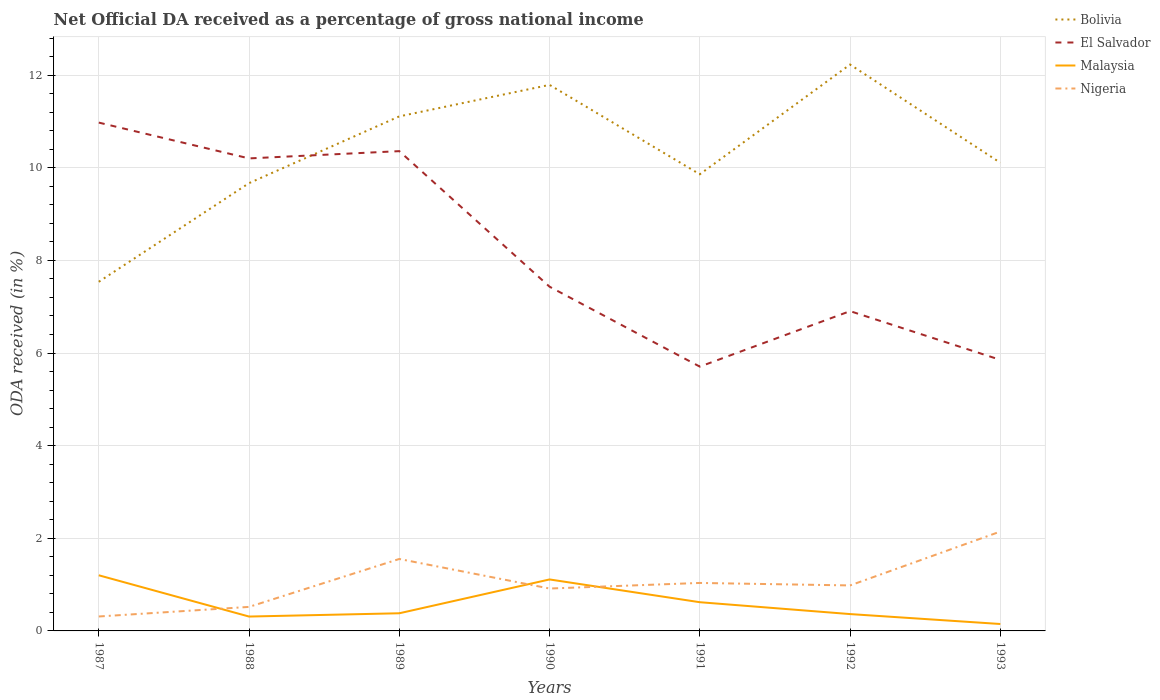How many different coloured lines are there?
Provide a succinct answer. 4. Across all years, what is the maximum net official DA received in Malaysia?
Your answer should be very brief. 0.15. What is the total net official DA received in Nigeria in the graph?
Provide a short and direct response. -0.07. What is the difference between the highest and the second highest net official DA received in Nigeria?
Offer a terse response. 1.83. Is the net official DA received in El Salvador strictly greater than the net official DA received in Bolivia over the years?
Your answer should be very brief. No. How many lines are there?
Make the answer very short. 4. Does the graph contain any zero values?
Your answer should be compact. No. How many legend labels are there?
Offer a terse response. 4. How are the legend labels stacked?
Provide a succinct answer. Vertical. What is the title of the graph?
Your answer should be compact. Net Official DA received as a percentage of gross national income. Does "Syrian Arab Republic" appear as one of the legend labels in the graph?
Keep it short and to the point. No. What is the label or title of the Y-axis?
Make the answer very short. ODA received (in %). What is the ODA received (in %) of Bolivia in 1987?
Provide a succinct answer. 7.54. What is the ODA received (in %) of El Salvador in 1987?
Keep it short and to the point. 10.98. What is the ODA received (in %) in Malaysia in 1987?
Offer a very short reply. 1.2. What is the ODA received (in %) in Nigeria in 1987?
Keep it short and to the point. 0.31. What is the ODA received (in %) of Bolivia in 1988?
Offer a very short reply. 9.67. What is the ODA received (in %) in El Salvador in 1988?
Give a very brief answer. 10.2. What is the ODA received (in %) of Malaysia in 1988?
Your answer should be very brief. 0.31. What is the ODA received (in %) in Nigeria in 1988?
Your answer should be compact. 0.52. What is the ODA received (in %) of Bolivia in 1989?
Your answer should be very brief. 11.11. What is the ODA received (in %) of El Salvador in 1989?
Provide a succinct answer. 10.36. What is the ODA received (in %) of Malaysia in 1989?
Offer a terse response. 0.38. What is the ODA received (in %) in Nigeria in 1989?
Provide a short and direct response. 1.55. What is the ODA received (in %) of Bolivia in 1990?
Make the answer very short. 11.79. What is the ODA received (in %) in El Salvador in 1990?
Keep it short and to the point. 7.43. What is the ODA received (in %) in Malaysia in 1990?
Ensure brevity in your answer.  1.11. What is the ODA received (in %) in Nigeria in 1990?
Provide a short and direct response. 0.92. What is the ODA received (in %) in Bolivia in 1991?
Give a very brief answer. 9.86. What is the ODA received (in %) in El Salvador in 1991?
Offer a terse response. 5.71. What is the ODA received (in %) in Malaysia in 1991?
Make the answer very short. 0.62. What is the ODA received (in %) in Nigeria in 1991?
Give a very brief answer. 1.04. What is the ODA received (in %) of Bolivia in 1992?
Give a very brief answer. 12.23. What is the ODA received (in %) of El Salvador in 1992?
Offer a terse response. 6.9. What is the ODA received (in %) in Malaysia in 1992?
Provide a succinct answer. 0.36. What is the ODA received (in %) in Nigeria in 1992?
Your answer should be very brief. 0.98. What is the ODA received (in %) of Bolivia in 1993?
Give a very brief answer. 10.11. What is the ODA received (in %) of El Salvador in 1993?
Offer a very short reply. 5.85. What is the ODA received (in %) in Malaysia in 1993?
Offer a terse response. 0.15. What is the ODA received (in %) of Nigeria in 1993?
Ensure brevity in your answer.  2.15. Across all years, what is the maximum ODA received (in %) in Bolivia?
Your response must be concise. 12.23. Across all years, what is the maximum ODA received (in %) in El Salvador?
Make the answer very short. 10.98. Across all years, what is the maximum ODA received (in %) of Malaysia?
Offer a terse response. 1.2. Across all years, what is the maximum ODA received (in %) of Nigeria?
Keep it short and to the point. 2.15. Across all years, what is the minimum ODA received (in %) of Bolivia?
Provide a short and direct response. 7.54. Across all years, what is the minimum ODA received (in %) in El Salvador?
Provide a succinct answer. 5.71. Across all years, what is the minimum ODA received (in %) in Malaysia?
Give a very brief answer. 0.15. Across all years, what is the minimum ODA received (in %) of Nigeria?
Give a very brief answer. 0.31. What is the total ODA received (in %) in Bolivia in the graph?
Offer a very short reply. 72.3. What is the total ODA received (in %) in El Salvador in the graph?
Give a very brief answer. 57.43. What is the total ODA received (in %) of Malaysia in the graph?
Keep it short and to the point. 4.14. What is the total ODA received (in %) in Nigeria in the graph?
Your answer should be compact. 7.46. What is the difference between the ODA received (in %) of Bolivia in 1987 and that in 1988?
Provide a succinct answer. -2.13. What is the difference between the ODA received (in %) in El Salvador in 1987 and that in 1988?
Your answer should be compact. 0.77. What is the difference between the ODA received (in %) in Malaysia in 1987 and that in 1988?
Your response must be concise. 0.89. What is the difference between the ODA received (in %) in Nigeria in 1987 and that in 1988?
Keep it short and to the point. -0.21. What is the difference between the ODA received (in %) of Bolivia in 1987 and that in 1989?
Offer a terse response. -3.57. What is the difference between the ODA received (in %) of El Salvador in 1987 and that in 1989?
Ensure brevity in your answer.  0.62. What is the difference between the ODA received (in %) in Malaysia in 1987 and that in 1989?
Your response must be concise. 0.82. What is the difference between the ODA received (in %) in Nigeria in 1987 and that in 1989?
Ensure brevity in your answer.  -1.24. What is the difference between the ODA received (in %) of Bolivia in 1987 and that in 1990?
Ensure brevity in your answer.  -4.25. What is the difference between the ODA received (in %) in El Salvador in 1987 and that in 1990?
Provide a short and direct response. 3.54. What is the difference between the ODA received (in %) in Malaysia in 1987 and that in 1990?
Your response must be concise. 0.09. What is the difference between the ODA received (in %) in Nigeria in 1987 and that in 1990?
Offer a terse response. -0.6. What is the difference between the ODA received (in %) of Bolivia in 1987 and that in 1991?
Your answer should be compact. -2.32. What is the difference between the ODA received (in %) in El Salvador in 1987 and that in 1991?
Your answer should be compact. 5.27. What is the difference between the ODA received (in %) in Malaysia in 1987 and that in 1991?
Your response must be concise. 0.58. What is the difference between the ODA received (in %) in Nigeria in 1987 and that in 1991?
Give a very brief answer. -0.72. What is the difference between the ODA received (in %) in Bolivia in 1987 and that in 1992?
Keep it short and to the point. -4.69. What is the difference between the ODA received (in %) of El Salvador in 1987 and that in 1992?
Ensure brevity in your answer.  4.07. What is the difference between the ODA received (in %) in Malaysia in 1987 and that in 1992?
Give a very brief answer. 0.84. What is the difference between the ODA received (in %) in Nigeria in 1987 and that in 1992?
Make the answer very short. -0.67. What is the difference between the ODA received (in %) of Bolivia in 1987 and that in 1993?
Your answer should be compact. -2.57. What is the difference between the ODA received (in %) of El Salvador in 1987 and that in 1993?
Provide a short and direct response. 5.12. What is the difference between the ODA received (in %) in Malaysia in 1987 and that in 1993?
Your answer should be very brief. 1.05. What is the difference between the ODA received (in %) of Nigeria in 1987 and that in 1993?
Keep it short and to the point. -1.83. What is the difference between the ODA received (in %) of Bolivia in 1988 and that in 1989?
Offer a terse response. -1.44. What is the difference between the ODA received (in %) in El Salvador in 1988 and that in 1989?
Provide a short and direct response. -0.16. What is the difference between the ODA received (in %) in Malaysia in 1988 and that in 1989?
Your response must be concise. -0.07. What is the difference between the ODA received (in %) of Nigeria in 1988 and that in 1989?
Your answer should be very brief. -1.03. What is the difference between the ODA received (in %) in Bolivia in 1988 and that in 1990?
Offer a terse response. -2.12. What is the difference between the ODA received (in %) of El Salvador in 1988 and that in 1990?
Make the answer very short. 2.77. What is the difference between the ODA received (in %) of Malaysia in 1988 and that in 1990?
Offer a terse response. -0.8. What is the difference between the ODA received (in %) of Nigeria in 1988 and that in 1990?
Make the answer very short. -0.4. What is the difference between the ODA received (in %) in Bolivia in 1988 and that in 1991?
Keep it short and to the point. -0.19. What is the difference between the ODA received (in %) in El Salvador in 1988 and that in 1991?
Your response must be concise. 4.5. What is the difference between the ODA received (in %) of Malaysia in 1988 and that in 1991?
Keep it short and to the point. -0.31. What is the difference between the ODA received (in %) in Nigeria in 1988 and that in 1991?
Your answer should be very brief. -0.52. What is the difference between the ODA received (in %) in Bolivia in 1988 and that in 1992?
Make the answer very short. -2.56. What is the difference between the ODA received (in %) of El Salvador in 1988 and that in 1992?
Provide a succinct answer. 3.3. What is the difference between the ODA received (in %) of Malaysia in 1988 and that in 1992?
Your answer should be very brief. -0.05. What is the difference between the ODA received (in %) in Nigeria in 1988 and that in 1992?
Your answer should be very brief. -0.46. What is the difference between the ODA received (in %) in Bolivia in 1988 and that in 1993?
Make the answer very short. -0.44. What is the difference between the ODA received (in %) of El Salvador in 1988 and that in 1993?
Your answer should be compact. 4.35. What is the difference between the ODA received (in %) in Malaysia in 1988 and that in 1993?
Your response must be concise. 0.16. What is the difference between the ODA received (in %) in Nigeria in 1988 and that in 1993?
Provide a short and direct response. -1.63. What is the difference between the ODA received (in %) of Bolivia in 1989 and that in 1990?
Your answer should be very brief. -0.68. What is the difference between the ODA received (in %) of El Salvador in 1989 and that in 1990?
Provide a succinct answer. 2.93. What is the difference between the ODA received (in %) of Malaysia in 1989 and that in 1990?
Keep it short and to the point. -0.73. What is the difference between the ODA received (in %) of Nigeria in 1989 and that in 1990?
Give a very brief answer. 0.64. What is the difference between the ODA received (in %) in Bolivia in 1989 and that in 1991?
Your response must be concise. 1.25. What is the difference between the ODA received (in %) of El Salvador in 1989 and that in 1991?
Provide a short and direct response. 4.65. What is the difference between the ODA received (in %) in Malaysia in 1989 and that in 1991?
Make the answer very short. -0.24. What is the difference between the ODA received (in %) in Nigeria in 1989 and that in 1991?
Your answer should be compact. 0.52. What is the difference between the ODA received (in %) of Bolivia in 1989 and that in 1992?
Keep it short and to the point. -1.12. What is the difference between the ODA received (in %) in El Salvador in 1989 and that in 1992?
Make the answer very short. 3.45. What is the difference between the ODA received (in %) of Malaysia in 1989 and that in 1992?
Your answer should be very brief. 0.02. What is the difference between the ODA received (in %) of Nigeria in 1989 and that in 1992?
Provide a succinct answer. 0.57. What is the difference between the ODA received (in %) in Bolivia in 1989 and that in 1993?
Keep it short and to the point. 1. What is the difference between the ODA received (in %) in El Salvador in 1989 and that in 1993?
Your answer should be very brief. 4.51. What is the difference between the ODA received (in %) in Malaysia in 1989 and that in 1993?
Provide a short and direct response. 0.23. What is the difference between the ODA received (in %) of Nigeria in 1989 and that in 1993?
Your answer should be compact. -0.59. What is the difference between the ODA received (in %) of Bolivia in 1990 and that in 1991?
Offer a very short reply. 1.93. What is the difference between the ODA received (in %) of El Salvador in 1990 and that in 1991?
Ensure brevity in your answer.  1.73. What is the difference between the ODA received (in %) of Malaysia in 1990 and that in 1991?
Provide a succinct answer. 0.49. What is the difference between the ODA received (in %) of Nigeria in 1990 and that in 1991?
Your answer should be very brief. -0.12. What is the difference between the ODA received (in %) of Bolivia in 1990 and that in 1992?
Provide a short and direct response. -0.44. What is the difference between the ODA received (in %) in El Salvador in 1990 and that in 1992?
Your response must be concise. 0.53. What is the difference between the ODA received (in %) in Malaysia in 1990 and that in 1992?
Ensure brevity in your answer.  0.75. What is the difference between the ODA received (in %) in Nigeria in 1990 and that in 1992?
Give a very brief answer. -0.07. What is the difference between the ODA received (in %) in Bolivia in 1990 and that in 1993?
Offer a terse response. 1.68. What is the difference between the ODA received (in %) in El Salvador in 1990 and that in 1993?
Offer a terse response. 1.58. What is the difference between the ODA received (in %) in Malaysia in 1990 and that in 1993?
Keep it short and to the point. 0.96. What is the difference between the ODA received (in %) of Nigeria in 1990 and that in 1993?
Provide a short and direct response. -1.23. What is the difference between the ODA received (in %) of Bolivia in 1991 and that in 1992?
Your response must be concise. -2.37. What is the difference between the ODA received (in %) in El Salvador in 1991 and that in 1992?
Offer a very short reply. -1.2. What is the difference between the ODA received (in %) in Malaysia in 1991 and that in 1992?
Give a very brief answer. 0.26. What is the difference between the ODA received (in %) of Nigeria in 1991 and that in 1992?
Your answer should be very brief. 0.05. What is the difference between the ODA received (in %) of Bolivia in 1991 and that in 1993?
Provide a short and direct response. -0.25. What is the difference between the ODA received (in %) in El Salvador in 1991 and that in 1993?
Your response must be concise. -0.15. What is the difference between the ODA received (in %) in Malaysia in 1991 and that in 1993?
Offer a very short reply. 0.47. What is the difference between the ODA received (in %) of Nigeria in 1991 and that in 1993?
Provide a succinct answer. -1.11. What is the difference between the ODA received (in %) in Bolivia in 1992 and that in 1993?
Offer a very short reply. 2.12. What is the difference between the ODA received (in %) in El Salvador in 1992 and that in 1993?
Your answer should be compact. 1.05. What is the difference between the ODA received (in %) in Malaysia in 1992 and that in 1993?
Provide a succinct answer. 0.21. What is the difference between the ODA received (in %) of Nigeria in 1992 and that in 1993?
Give a very brief answer. -1.16. What is the difference between the ODA received (in %) of Bolivia in 1987 and the ODA received (in %) of El Salvador in 1988?
Keep it short and to the point. -2.66. What is the difference between the ODA received (in %) of Bolivia in 1987 and the ODA received (in %) of Malaysia in 1988?
Keep it short and to the point. 7.23. What is the difference between the ODA received (in %) of Bolivia in 1987 and the ODA received (in %) of Nigeria in 1988?
Your answer should be very brief. 7.02. What is the difference between the ODA received (in %) of El Salvador in 1987 and the ODA received (in %) of Malaysia in 1988?
Give a very brief answer. 10.66. What is the difference between the ODA received (in %) in El Salvador in 1987 and the ODA received (in %) in Nigeria in 1988?
Provide a short and direct response. 10.46. What is the difference between the ODA received (in %) in Malaysia in 1987 and the ODA received (in %) in Nigeria in 1988?
Make the answer very short. 0.68. What is the difference between the ODA received (in %) of Bolivia in 1987 and the ODA received (in %) of El Salvador in 1989?
Your answer should be very brief. -2.82. What is the difference between the ODA received (in %) in Bolivia in 1987 and the ODA received (in %) in Malaysia in 1989?
Offer a terse response. 7.16. What is the difference between the ODA received (in %) in Bolivia in 1987 and the ODA received (in %) in Nigeria in 1989?
Ensure brevity in your answer.  5.98. What is the difference between the ODA received (in %) in El Salvador in 1987 and the ODA received (in %) in Malaysia in 1989?
Give a very brief answer. 10.59. What is the difference between the ODA received (in %) of El Salvador in 1987 and the ODA received (in %) of Nigeria in 1989?
Offer a terse response. 9.42. What is the difference between the ODA received (in %) in Malaysia in 1987 and the ODA received (in %) in Nigeria in 1989?
Offer a terse response. -0.35. What is the difference between the ODA received (in %) of Bolivia in 1987 and the ODA received (in %) of El Salvador in 1990?
Your answer should be very brief. 0.11. What is the difference between the ODA received (in %) of Bolivia in 1987 and the ODA received (in %) of Malaysia in 1990?
Provide a short and direct response. 6.43. What is the difference between the ODA received (in %) in Bolivia in 1987 and the ODA received (in %) in Nigeria in 1990?
Offer a terse response. 6.62. What is the difference between the ODA received (in %) in El Salvador in 1987 and the ODA received (in %) in Malaysia in 1990?
Your response must be concise. 9.86. What is the difference between the ODA received (in %) of El Salvador in 1987 and the ODA received (in %) of Nigeria in 1990?
Give a very brief answer. 10.06. What is the difference between the ODA received (in %) of Malaysia in 1987 and the ODA received (in %) of Nigeria in 1990?
Offer a very short reply. 0.29. What is the difference between the ODA received (in %) in Bolivia in 1987 and the ODA received (in %) in El Salvador in 1991?
Your answer should be very brief. 1.83. What is the difference between the ODA received (in %) in Bolivia in 1987 and the ODA received (in %) in Malaysia in 1991?
Ensure brevity in your answer.  6.92. What is the difference between the ODA received (in %) in Bolivia in 1987 and the ODA received (in %) in Nigeria in 1991?
Provide a succinct answer. 6.5. What is the difference between the ODA received (in %) of El Salvador in 1987 and the ODA received (in %) of Malaysia in 1991?
Keep it short and to the point. 10.36. What is the difference between the ODA received (in %) in El Salvador in 1987 and the ODA received (in %) in Nigeria in 1991?
Give a very brief answer. 9.94. What is the difference between the ODA received (in %) of Malaysia in 1987 and the ODA received (in %) of Nigeria in 1991?
Offer a very short reply. 0.17. What is the difference between the ODA received (in %) of Bolivia in 1987 and the ODA received (in %) of El Salvador in 1992?
Ensure brevity in your answer.  0.63. What is the difference between the ODA received (in %) of Bolivia in 1987 and the ODA received (in %) of Malaysia in 1992?
Give a very brief answer. 7.17. What is the difference between the ODA received (in %) in Bolivia in 1987 and the ODA received (in %) in Nigeria in 1992?
Make the answer very short. 6.56. What is the difference between the ODA received (in %) in El Salvador in 1987 and the ODA received (in %) in Malaysia in 1992?
Keep it short and to the point. 10.61. What is the difference between the ODA received (in %) of El Salvador in 1987 and the ODA received (in %) of Nigeria in 1992?
Ensure brevity in your answer.  9.99. What is the difference between the ODA received (in %) of Malaysia in 1987 and the ODA received (in %) of Nigeria in 1992?
Provide a short and direct response. 0.22. What is the difference between the ODA received (in %) of Bolivia in 1987 and the ODA received (in %) of El Salvador in 1993?
Give a very brief answer. 1.69. What is the difference between the ODA received (in %) of Bolivia in 1987 and the ODA received (in %) of Malaysia in 1993?
Make the answer very short. 7.39. What is the difference between the ODA received (in %) of Bolivia in 1987 and the ODA received (in %) of Nigeria in 1993?
Ensure brevity in your answer.  5.39. What is the difference between the ODA received (in %) in El Salvador in 1987 and the ODA received (in %) in Malaysia in 1993?
Your answer should be compact. 10.83. What is the difference between the ODA received (in %) in El Salvador in 1987 and the ODA received (in %) in Nigeria in 1993?
Your answer should be compact. 8.83. What is the difference between the ODA received (in %) of Malaysia in 1987 and the ODA received (in %) of Nigeria in 1993?
Provide a succinct answer. -0.94. What is the difference between the ODA received (in %) in Bolivia in 1988 and the ODA received (in %) in El Salvador in 1989?
Provide a succinct answer. -0.69. What is the difference between the ODA received (in %) of Bolivia in 1988 and the ODA received (in %) of Malaysia in 1989?
Provide a succinct answer. 9.29. What is the difference between the ODA received (in %) in Bolivia in 1988 and the ODA received (in %) in Nigeria in 1989?
Offer a very short reply. 8.11. What is the difference between the ODA received (in %) of El Salvador in 1988 and the ODA received (in %) of Malaysia in 1989?
Your response must be concise. 9.82. What is the difference between the ODA received (in %) in El Salvador in 1988 and the ODA received (in %) in Nigeria in 1989?
Offer a terse response. 8.65. What is the difference between the ODA received (in %) of Malaysia in 1988 and the ODA received (in %) of Nigeria in 1989?
Give a very brief answer. -1.24. What is the difference between the ODA received (in %) of Bolivia in 1988 and the ODA received (in %) of El Salvador in 1990?
Make the answer very short. 2.24. What is the difference between the ODA received (in %) of Bolivia in 1988 and the ODA received (in %) of Malaysia in 1990?
Provide a succinct answer. 8.56. What is the difference between the ODA received (in %) of Bolivia in 1988 and the ODA received (in %) of Nigeria in 1990?
Ensure brevity in your answer.  8.75. What is the difference between the ODA received (in %) in El Salvador in 1988 and the ODA received (in %) in Malaysia in 1990?
Keep it short and to the point. 9.09. What is the difference between the ODA received (in %) of El Salvador in 1988 and the ODA received (in %) of Nigeria in 1990?
Your response must be concise. 9.29. What is the difference between the ODA received (in %) of Malaysia in 1988 and the ODA received (in %) of Nigeria in 1990?
Your answer should be compact. -0.6. What is the difference between the ODA received (in %) of Bolivia in 1988 and the ODA received (in %) of El Salvador in 1991?
Your response must be concise. 3.96. What is the difference between the ODA received (in %) in Bolivia in 1988 and the ODA received (in %) in Malaysia in 1991?
Keep it short and to the point. 9.05. What is the difference between the ODA received (in %) in Bolivia in 1988 and the ODA received (in %) in Nigeria in 1991?
Your answer should be compact. 8.63. What is the difference between the ODA received (in %) of El Salvador in 1988 and the ODA received (in %) of Malaysia in 1991?
Keep it short and to the point. 9.58. What is the difference between the ODA received (in %) of El Salvador in 1988 and the ODA received (in %) of Nigeria in 1991?
Provide a short and direct response. 9.17. What is the difference between the ODA received (in %) in Malaysia in 1988 and the ODA received (in %) in Nigeria in 1991?
Provide a succinct answer. -0.73. What is the difference between the ODA received (in %) in Bolivia in 1988 and the ODA received (in %) in El Salvador in 1992?
Give a very brief answer. 2.76. What is the difference between the ODA received (in %) in Bolivia in 1988 and the ODA received (in %) in Malaysia in 1992?
Your response must be concise. 9.3. What is the difference between the ODA received (in %) of Bolivia in 1988 and the ODA received (in %) of Nigeria in 1992?
Give a very brief answer. 8.69. What is the difference between the ODA received (in %) of El Salvador in 1988 and the ODA received (in %) of Malaysia in 1992?
Give a very brief answer. 9.84. What is the difference between the ODA received (in %) of El Salvador in 1988 and the ODA received (in %) of Nigeria in 1992?
Provide a short and direct response. 9.22. What is the difference between the ODA received (in %) of Malaysia in 1988 and the ODA received (in %) of Nigeria in 1992?
Offer a very short reply. -0.67. What is the difference between the ODA received (in %) of Bolivia in 1988 and the ODA received (in %) of El Salvador in 1993?
Your answer should be very brief. 3.82. What is the difference between the ODA received (in %) of Bolivia in 1988 and the ODA received (in %) of Malaysia in 1993?
Ensure brevity in your answer.  9.52. What is the difference between the ODA received (in %) of Bolivia in 1988 and the ODA received (in %) of Nigeria in 1993?
Provide a succinct answer. 7.52. What is the difference between the ODA received (in %) in El Salvador in 1988 and the ODA received (in %) in Malaysia in 1993?
Offer a very short reply. 10.05. What is the difference between the ODA received (in %) of El Salvador in 1988 and the ODA received (in %) of Nigeria in 1993?
Provide a short and direct response. 8.06. What is the difference between the ODA received (in %) of Malaysia in 1988 and the ODA received (in %) of Nigeria in 1993?
Keep it short and to the point. -1.84. What is the difference between the ODA received (in %) of Bolivia in 1989 and the ODA received (in %) of El Salvador in 1990?
Offer a terse response. 3.68. What is the difference between the ODA received (in %) of Bolivia in 1989 and the ODA received (in %) of Malaysia in 1990?
Provide a succinct answer. 10. What is the difference between the ODA received (in %) in Bolivia in 1989 and the ODA received (in %) in Nigeria in 1990?
Offer a terse response. 10.19. What is the difference between the ODA received (in %) of El Salvador in 1989 and the ODA received (in %) of Malaysia in 1990?
Your response must be concise. 9.25. What is the difference between the ODA received (in %) in El Salvador in 1989 and the ODA received (in %) in Nigeria in 1990?
Your answer should be compact. 9.44. What is the difference between the ODA received (in %) in Malaysia in 1989 and the ODA received (in %) in Nigeria in 1990?
Provide a short and direct response. -0.53. What is the difference between the ODA received (in %) of Bolivia in 1989 and the ODA received (in %) of El Salvador in 1991?
Make the answer very short. 5.4. What is the difference between the ODA received (in %) in Bolivia in 1989 and the ODA received (in %) in Malaysia in 1991?
Your response must be concise. 10.49. What is the difference between the ODA received (in %) in Bolivia in 1989 and the ODA received (in %) in Nigeria in 1991?
Offer a very short reply. 10.07. What is the difference between the ODA received (in %) in El Salvador in 1989 and the ODA received (in %) in Malaysia in 1991?
Offer a terse response. 9.74. What is the difference between the ODA received (in %) of El Salvador in 1989 and the ODA received (in %) of Nigeria in 1991?
Your answer should be compact. 9.32. What is the difference between the ODA received (in %) of Malaysia in 1989 and the ODA received (in %) of Nigeria in 1991?
Your response must be concise. -0.65. What is the difference between the ODA received (in %) of Bolivia in 1989 and the ODA received (in %) of El Salvador in 1992?
Keep it short and to the point. 4.2. What is the difference between the ODA received (in %) of Bolivia in 1989 and the ODA received (in %) of Malaysia in 1992?
Your response must be concise. 10.75. What is the difference between the ODA received (in %) in Bolivia in 1989 and the ODA received (in %) in Nigeria in 1992?
Offer a very short reply. 10.13. What is the difference between the ODA received (in %) in El Salvador in 1989 and the ODA received (in %) in Malaysia in 1992?
Give a very brief answer. 10. What is the difference between the ODA received (in %) of El Salvador in 1989 and the ODA received (in %) of Nigeria in 1992?
Offer a very short reply. 9.38. What is the difference between the ODA received (in %) of Malaysia in 1989 and the ODA received (in %) of Nigeria in 1992?
Ensure brevity in your answer.  -0.6. What is the difference between the ODA received (in %) of Bolivia in 1989 and the ODA received (in %) of El Salvador in 1993?
Offer a terse response. 5.26. What is the difference between the ODA received (in %) of Bolivia in 1989 and the ODA received (in %) of Malaysia in 1993?
Your response must be concise. 10.96. What is the difference between the ODA received (in %) in Bolivia in 1989 and the ODA received (in %) in Nigeria in 1993?
Provide a succinct answer. 8.96. What is the difference between the ODA received (in %) of El Salvador in 1989 and the ODA received (in %) of Malaysia in 1993?
Ensure brevity in your answer.  10.21. What is the difference between the ODA received (in %) in El Salvador in 1989 and the ODA received (in %) in Nigeria in 1993?
Give a very brief answer. 8.21. What is the difference between the ODA received (in %) in Malaysia in 1989 and the ODA received (in %) in Nigeria in 1993?
Keep it short and to the point. -1.76. What is the difference between the ODA received (in %) in Bolivia in 1990 and the ODA received (in %) in El Salvador in 1991?
Make the answer very short. 6.08. What is the difference between the ODA received (in %) in Bolivia in 1990 and the ODA received (in %) in Malaysia in 1991?
Offer a very short reply. 11.17. What is the difference between the ODA received (in %) in Bolivia in 1990 and the ODA received (in %) in Nigeria in 1991?
Ensure brevity in your answer.  10.75. What is the difference between the ODA received (in %) of El Salvador in 1990 and the ODA received (in %) of Malaysia in 1991?
Provide a succinct answer. 6.81. What is the difference between the ODA received (in %) in El Salvador in 1990 and the ODA received (in %) in Nigeria in 1991?
Offer a terse response. 6.4. What is the difference between the ODA received (in %) in Malaysia in 1990 and the ODA received (in %) in Nigeria in 1991?
Offer a very short reply. 0.08. What is the difference between the ODA received (in %) of Bolivia in 1990 and the ODA received (in %) of El Salvador in 1992?
Offer a very short reply. 4.88. What is the difference between the ODA received (in %) in Bolivia in 1990 and the ODA received (in %) in Malaysia in 1992?
Offer a terse response. 11.43. What is the difference between the ODA received (in %) in Bolivia in 1990 and the ODA received (in %) in Nigeria in 1992?
Ensure brevity in your answer.  10.81. What is the difference between the ODA received (in %) in El Salvador in 1990 and the ODA received (in %) in Malaysia in 1992?
Your answer should be very brief. 7.07. What is the difference between the ODA received (in %) of El Salvador in 1990 and the ODA received (in %) of Nigeria in 1992?
Give a very brief answer. 6.45. What is the difference between the ODA received (in %) in Malaysia in 1990 and the ODA received (in %) in Nigeria in 1992?
Ensure brevity in your answer.  0.13. What is the difference between the ODA received (in %) of Bolivia in 1990 and the ODA received (in %) of El Salvador in 1993?
Your answer should be very brief. 5.94. What is the difference between the ODA received (in %) of Bolivia in 1990 and the ODA received (in %) of Malaysia in 1993?
Your response must be concise. 11.64. What is the difference between the ODA received (in %) of Bolivia in 1990 and the ODA received (in %) of Nigeria in 1993?
Provide a succinct answer. 9.64. What is the difference between the ODA received (in %) of El Salvador in 1990 and the ODA received (in %) of Malaysia in 1993?
Offer a terse response. 7.28. What is the difference between the ODA received (in %) of El Salvador in 1990 and the ODA received (in %) of Nigeria in 1993?
Provide a succinct answer. 5.29. What is the difference between the ODA received (in %) in Malaysia in 1990 and the ODA received (in %) in Nigeria in 1993?
Give a very brief answer. -1.03. What is the difference between the ODA received (in %) in Bolivia in 1991 and the ODA received (in %) in El Salvador in 1992?
Ensure brevity in your answer.  2.95. What is the difference between the ODA received (in %) of Bolivia in 1991 and the ODA received (in %) of Malaysia in 1992?
Provide a short and direct response. 9.5. What is the difference between the ODA received (in %) of Bolivia in 1991 and the ODA received (in %) of Nigeria in 1992?
Your answer should be very brief. 8.88. What is the difference between the ODA received (in %) in El Salvador in 1991 and the ODA received (in %) in Malaysia in 1992?
Provide a succinct answer. 5.34. What is the difference between the ODA received (in %) of El Salvador in 1991 and the ODA received (in %) of Nigeria in 1992?
Your answer should be compact. 4.72. What is the difference between the ODA received (in %) in Malaysia in 1991 and the ODA received (in %) in Nigeria in 1992?
Provide a short and direct response. -0.36. What is the difference between the ODA received (in %) in Bolivia in 1991 and the ODA received (in %) in El Salvador in 1993?
Make the answer very short. 4.01. What is the difference between the ODA received (in %) in Bolivia in 1991 and the ODA received (in %) in Malaysia in 1993?
Provide a succinct answer. 9.71. What is the difference between the ODA received (in %) of Bolivia in 1991 and the ODA received (in %) of Nigeria in 1993?
Ensure brevity in your answer.  7.71. What is the difference between the ODA received (in %) of El Salvador in 1991 and the ODA received (in %) of Malaysia in 1993?
Keep it short and to the point. 5.56. What is the difference between the ODA received (in %) in El Salvador in 1991 and the ODA received (in %) in Nigeria in 1993?
Your response must be concise. 3.56. What is the difference between the ODA received (in %) of Malaysia in 1991 and the ODA received (in %) of Nigeria in 1993?
Offer a very short reply. -1.53. What is the difference between the ODA received (in %) of Bolivia in 1992 and the ODA received (in %) of El Salvador in 1993?
Give a very brief answer. 6.38. What is the difference between the ODA received (in %) in Bolivia in 1992 and the ODA received (in %) in Malaysia in 1993?
Your answer should be compact. 12.08. What is the difference between the ODA received (in %) of Bolivia in 1992 and the ODA received (in %) of Nigeria in 1993?
Your answer should be compact. 10.08. What is the difference between the ODA received (in %) in El Salvador in 1992 and the ODA received (in %) in Malaysia in 1993?
Provide a succinct answer. 6.76. What is the difference between the ODA received (in %) of El Salvador in 1992 and the ODA received (in %) of Nigeria in 1993?
Offer a terse response. 4.76. What is the difference between the ODA received (in %) in Malaysia in 1992 and the ODA received (in %) in Nigeria in 1993?
Offer a very short reply. -1.78. What is the average ODA received (in %) in Bolivia per year?
Offer a very short reply. 10.33. What is the average ODA received (in %) in El Salvador per year?
Your answer should be compact. 8.2. What is the average ODA received (in %) of Malaysia per year?
Provide a short and direct response. 0.59. What is the average ODA received (in %) in Nigeria per year?
Offer a terse response. 1.07. In the year 1987, what is the difference between the ODA received (in %) of Bolivia and ODA received (in %) of El Salvador?
Offer a terse response. -3.44. In the year 1987, what is the difference between the ODA received (in %) of Bolivia and ODA received (in %) of Malaysia?
Your answer should be compact. 6.34. In the year 1987, what is the difference between the ODA received (in %) of Bolivia and ODA received (in %) of Nigeria?
Provide a succinct answer. 7.23. In the year 1987, what is the difference between the ODA received (in %) of El Salvador and ODA received (in %) of Malaysia?
Your answer should be compact. 9.77. In the year 1987, what is the difference between the ODA received (in %) in El Salvador and ODA received (in %) in Nigeria?
Make the answer very short. 10.66. In the year 1987, what is the difference between the ODA received (in %) of Malaysia and ODA received (in %) of Nigeria?
Your response must be concise. 0.89. In the year 1988, what is the difference between the ODA received (in %) of Bolivia and ODA received (in %) of El Salvador?
Offer a very short reply. -0.53. In the year 1988, what is the difference between the ODA received (in %) in Bolivia and ODA received (in %) in Malaysia?
Your response must be concise. 9.36. In the year 1988, what is the difference between the ODA received (in %) of Bolivia and ODA received (in %) of Nigeria?
Offer a terse response. 9.15. In the year 1988, what is the difference between the ODA received (in %) of El Salvador and ODA received (in %) of Malaysia?
Your answer should be compact. 9.89. In the year 1988, what is the difference between the ODA received (in %) in El Salvador and ODA received (in %) in Nigeria?
Your response must be concise. 9.68. In the year 1988, what is the difference between the ODA received (in %) of Malaysia and ODA received (in %) of Nigeria?
Make the answer very short. -0.21. In the year 1989, what is the difference between the ODA received (in %) of Bolivia and ODA received (in %) of El Salvador?
Your answer should be very brief. 0.75. In the year 1989, what is the difference between the ODA received (in %) of Bolivia and ODA received (in %) of Malaysia?
Your answer should be very brief. 10.73. In the year 1989, what is the difference between the ODA received (in %) in Bolivia and ODA received (in %) in Nigeria?
Offer a terse response. 9.56. In the year 1989, what is the difference between the ODA received (in %) in El Salvador and ODA received (in %) in Malaysia?
Keep it short and to the point. 9.98. In the year 1989, what is the difference between the ODA received (in %) in El Salvador and ODA received (in %) in Nigeria?
Your response must be concise. 8.81. In the year 1989, what is the difference between the ODA received (in %) in Malaysia and ODA received (in %) in Nigeria?
Make the answer very short. -1.17. In the year 1990, what is the difference between the ODA received (in %) in Bolivia and ODA received (in %) in El Salvador?
Provide a succinct answer. 4.36. In the year 1990, what is the difference between the ODA received (in %) in Bolivia and ODA received (in %) in Malaysia?
Provide a succinct answer. 10.68. In the year 1990, what is the difference between the ODA received (in %) in Bolivia and ODA received (in %) in Nigeria?
Your answer should be compact. 10.87. In the year 1990, what is the difference between the ODA received (in %) of El Salvador and ODA received (in %) of Malaysia?
Ensure brevity in your answer.  6.32. In the year 1990, what is the difference between the ODA received (in %) in El Salvador and ODA received (in %) in Nigeria?
Keep it short and to the point. 6.52. In the year 1990, what is the difference between the ODA received (in %) in Malaysia and ODA received (in %) in Nigeria?
Your answer should be compact. 0.2. In the year 1991, what is the difference between the ODA received (in %) in Bolivia and ODA received (in %) in El Salvador?
Offer a terse response. 4.15. In the year 1991, what is the difference between the ODA received (in %) in Bolivia and ODA received (in %) in Malaysia?
Provide a succinct answer. 9.24. In the year 1991, what is the difference between the ODA received (in %) of Bolivia and ODA received (in %) of Nigeria?
Your response must be concise. 8.82. In the year 1991, what is the difference between the ODA received (in %) in El Salvador and ODA received (in %) in Malaysia?
Offer a very short reply. 5.09. In the year 1991, what is the difference between the ODA received (in %) of El Salvador and ODA received (in %) of Nigeria?
Make the answer very short. 4.67. In the year 1991, what is the difference between the ODA received (in %) of Malaysia and ODA received (in %) of Nigeria?
Offer a terse response. -0.42. In the year 1992, what is the difference between the ODA received (in %) in Bolivia and ODA received (in %) in El Salvador?
Make the answer very short. 5.32. In the year 1992, what is the difference between the ODA received (in %) in Bolivia and ODA received (in %) in Malaysia?
Your response must be concise. 11.86. In the year 1992, what is the difference between the ODA received (in %) in Bolivia and ODA received (in %) in Nigeria?
Provide a short and direct response. 11.25. In the year 1992, what is the difference between the ODA received (in %) of El Salvador and ODA received (in %) of Malaysia?
Your response must be concise. 6.54. In the year 1992, what is the difference between the ODA received (in %) in El Salvador and ODA received (in %) in Nigeria?
Make the answer very short. 5.92. In the year 1992, what is the difference between the ODA received (in %) of Malaysia and ODA received (in %) of Nigeria?
Give a very brief answer. -0.62. In the year 1993, what is the difference between the ODA received (in %) in Bolivia and ODA received (in %) in El Salvador?
Keep it short and to the point. 4.26. In the year 1993, what is the difference between the ODA received (in %) in Bolivia and ODA received (in %) in Malaysia?
Your response must be concise. 9.96. In the year 1993, what is the difference between the ODA received (in %) in Bolivia and ODA received (in %) in Nigeria?
Ensure brevity in your answer.  7.96. In the year 1993, what is the difference between the ODA received (in %) of El Salvador and ODA received (in %) of Malaysia?
Make the answer very short. 5.7. In the year 1993, what is the difference between the ODA received (in %) in El Salvador and ODA received (in %) in Nigeria?
Your answer should be very brief. 3.71. In the year 1993, what is the difference between the ODA received (in %) of Malaysia and ODA received (in %) of Nigeria?
Give a very brief answer. -2. What is the ratio of the ODA received (in %) in Bolivia in 1987 to that in 1988?
Give a very brief answer. 0.78. What is the ratio of the ODA received (in %) in El Salvador in 1987 to that in 1988?
Provide a short and direct response. 1.08. What is the ratio of the ODA received (in %) of Malaysia in 1987 to that in 1988?
Make the answer very short. 3.87. What is the ratio of the ODA received (in %) in Nigeria in 1987 to that in 1988?
Keep it short and to the point. 0.6. What is the ratio of the ODA received (in %) in Bolivia in 1987 to that in 1989?
Offer a terse response. 0.68. What is the ratio of the ODA received (in %) in El Salvador in 1987 to that in 1989?
Offer a very short reply. 1.06. What is the ratio of the ODA received (in %) of Malaysia in 1987 to that in 1989?
Provide a succinct answer. 3.15. What is the ratio of the ODA received (in %) in Nigeria in 1987 to that in 1989?
Your answer should be compact. 0.2. What is the ratio of the ODA received (in %) of Bolivia in 1987 to that in 1990?
Your response must be concise. 0.64. What is the ratio of the ODA received (in %) in El Salvador in 1987 to that in 1990?
Your answer should be very brief. 1.48. What is the ratio of the ODA received (in %) of Malaysia in 1987 to that in 1990?
Offer a terse response. 1.08. What is the ratio of the ODA received (in %) of Nigeria in 1987 to that in 1990?
Your answer should be compact. 0.34. What is the ratio of the ODA received (in %) of Bolivia in 1987 to that in 1991?
Provide a succinct answer. 0.76. What is the ratio of the ODA received (in %) of El Salvador in 1987 to that in 1991?
Ensure brevity in your answer.  1.92. What is the ratio of the ODA received (in %) in Malaysia in 1987 to that in 1991?
Provide a short and direct response. 1.94. What is the ratio of the ODA received (in %) in Nigeria in 1987 to that in 1991?
Ensure brevity in your answer.  0.3. What is the ratio of the ODA received (in %) in Bolivia in 1987 to that in 1992?
Ensure brevity in your answer.  0.62. What is the ratio of the ODA received (in %) of El Salvador in 1987 to that in 1992?
Your answer should be very brief. 1.59. What is the ratio of the ODA received (in %) in Malaysia in 1987 to that in 1992?
Make the answer very short. 3.3. What is the ratio of the ODA received (in %) in Nigeria in 1987 to that in 1992?
Offer a very short reply. 0.32. What is the ratio of the ODA received (in %) of Bolivia in 1987 to that in 1993?
Offer a terse response. 0.75. What is the ratio of the ODA received (in %) of El Salvador in 1987 to that in 1993?
Offer a very short reply. 1.88. What is the ratio of the ODA received (in %) in Malaysia in 1987 to that in 1993?
Provide a short and direct response. 8.03. What is the ratio of the ODA received (in %) in Nigeria in 1987 to that in 1993?
Give a very brief answer. 0.15. What is the ratio of the ODA received (in %) of Bolivia in 1988 to that in 1989?
Provide a short and direct response. 0.87. What is the ratio of the ODA received (in %) in El Salvador in 1988 to that in 1989?
Your response must be concise. 0.98. What is the ratio of the ODA received (in %) in Malaysia in 1988 to that in 1989?
Ensure brevity in your answer.  0.81. What is the ratio of the ODA received (in %) in Nigeria in 1988 to that in 1989?
Provide a succinct answer. 0.33. What is the ratio of the ODA received (in %) of Bolivia in 1988 to that in 1990?
Offer a terse response. 0.82. What is the ratio of the ODA received (in %) of El Salvador in 1988 to that in 1990?
Keep it short and to the point. 1.37. What is the ratio of the ODA received (in %) of Malaysia in 1988 to that in 1990?
Provide a succinct answer. 0.28. What is the ratio of the ODA received (in %) in Nigeria in 1988 to that in 1990?
Offer a very short reply. 0.57. What is the ratio of the ODA received (in %) of Bolivia in 1988 to that in 1991?
Keep it short and to the point. 0.98. What is the ratio of the ODA received (in %) in El Salvador in 1988 to that in 1991?
Make the answer very short. 1.79. What is the ratio of the ODA received (in %) in Malaysia in 1988 to that in 1991?
Offer a very short reply. 0.5. What is the ratio of the ODA received (in %) in Nigeria in 1988 to that in 1991?
Your answer should be compact. 0.5. What is the ratio of the ODA received (in %) in Bolivia in 1988 to that in 1992?
Give a very brief answer. 0.79. What is the ratio of the ODA received (in %) in El Salvador in 1988 to that in 1992?
Give a very brief answer. 1.48. What is the ratio of the ODA received (in %) of Malaysia in 1988 to that in 1992?
Ensure brevity in your answer.  0.85. What is the ratio of the ODA received (in %) of Nigeria in 1988 to that in 1992?
Offer a terse response. 0.53. What is the ratio of the ODA received (in %) of Bolivia in 1988 to that in 1993?
Provide a short and direct response. 0.96. What is the ratio of the ODA received (in %) of El Salvador in 1988 to that in 1993?
Ensure brevity in your answer.  1.74. What is the ratio of the ODA received (in %) in Malaysia in 1988 to that in 1993?
Your answer should be very brief. 2.08. What is the ratio of the ODA received (in %) of Nigeria in 1988 to that in 1993?
Keep it short and to the point. 0.24. What is the ratio of the ODA received (in %) in Bolivia in 1989 to that in 1990?
Your answer should be very brief. 0.94. What is the ratio of the ODA received (in %) in El Salvador in 1989 to that in 1990?
Keep it short and to the point. 1.39. What is the ratio of the ODA received (in %) of Malaysia in 1989 to that in 1990?
Make the answer very short. 0.34. What is the ratio of the ODA received (in %) in Nigeria in 1989 to that in 1990?
Ensure brevity in your answer.  1.7. What is the ratio of the ODA received (in %) of Bolivia in 1989 to that in 1991?
Make the answer very short. 1.13. What is the ratio of the ODA received (in %) in El Salvador in 1989 to that in 1991?
Ensure brevity in your answer.  1.82. What is the ratio of the ODA received (in %) in Malaysia in 1989 to that in 1991?
Make the answer very short. 0.61. What is the ratio of the ODA received (in %) of Nigeria in 1989 to that in 1991?
Provide a short and direct response. 1.5. What is the ratio of the ODA received (in %) in Bolivia in 1989 to that in 1992?
Ensure brevity in your answer.  0.91. What is the ratio of the ODA received (in %) in El Salvador in 1989 to that in 1992?
Your answer should be very brief. 1.5. What is the ratio of the ODA received (in %) of Malaysia in 1989 to that in 1992?
Provide a short and direct response. 1.05. What is the ratio of the ODA received (in %) in Nigeria in 1989 to that in 1992?
Your response must be concise. 1.58. What is the ratio of the ODA received (in %) of Bolivia in 1989 to that in 1993?
Provide a succinct answer. 1.1. What is the ratio of the ODA received (in %) of El Salvador in 1989 to that in 1993?
Your answer should be very brief. 1.77. What is the ratio of the ODA received (in %) of Malaysia in 1989 to that in 1993?
Your response must be concise. 2.55. What is the ratio of the ODA received (in %) in Nigeria in 1989 to that in 1993?
Your answer should be compact. 0.72. What is the ratio of the ODA received (in %) in Bolivia in 1990 to that in 1991?
Make the answer very short. 1.2. What is the ratio of the ODA received (in %) in El Salvador in 1990 to that in 1991?
Keep it short and to the point. 1.3. What is the ratio of the ODA received (in %) in Malaysia in 1990 to that in 1991?
Make the answer very short. 1.79. What is the ratio of the ODA received (in %) of Nigeria in 1990 to that in 1991?
Keep it short and to the point. 0.88. What is the ratio of the ODA received (in %) of Bolivia in 1990 to that in 1992?
Offer a terse response. 0.96. What is the ratio of the ODA received (in %) in El Salvador in 1990 to that in 1992?
Give a very brief answer. 1.08. What is the ratio of the ODA received (in %) of Malaysia in 1990 to that in 1992?
Keep it short and to the point. 3.06. What is the ratio of the ODA received (in %) of Nigeria in 1990 to that in 1992?
Your response must be concise. 0.93. What is the ratio of the ODA received (in %) in Bolivia in 1990 to that in 1993?
Make the answer very short. 1.17. What is the ratio of the ODA received (in %) in El Salvador in 1990 to that in 1993?
Ensure brevity in your answer.  1.27. What is the ratio of the ODA received (in %) of Malaysia in 1990 to that in 1993?
Your answer should be very brief. 7.43. What is the ratio of the ODA received (in %) in Nigeria in 1990 to that in 1993?
Ensure brevity in your answer.  0.43. What is the ratio of the ODA received (in %) of Bolivia in 1991 to that in 1992?
Ensure brevity in your answer.  0.81. What is the ratio of the ODA received (in %) in El Salvador in 1991 to that in 1992?
Your answer should be very brief. 0.83. What is the ratio of the ODA received (in %) in Malaysia in 1991 to that in 1992?
Keep it short and to the point. 1.7. What is the ratio of the ODA received (in %) in Nigeria in 1991 to that in 1992?
Keep it short and to the point. 1.05. What is the ratio of the ODA received (in %) of Bolivia in 1991 to that in 1993?
Your answer should be compact. 0.98. What is the ratio of the ODA received (in %) of El Salvador in 1991 to that in 1993?
Your answer should be very brief. 0.97. What is the ratio of the ODA received (in %) of Malaysia in 1991 to that in 1993?
Ensure brevity in your answer.  4.15. What is the ratio of the ODA received (in %) of Nigeria in 1991 to that in 1993?
Give a very brief answer. 0.48. What is the ratio of the ODA received (in %) of Bolivia in 1992 to that in 1993?
Give a very brief answer. 1.21. What is the ratio of the ODA received (in %) in El Salvador in 1992 to that in 1993?
Provide a short and direct response. 1.18. What is the ratio of the ODA received (in %) in Malaysia in 1992 to that in 1993?
Your response must be concise. 2.43. What is the ratio of the ODA received (in %) in Nigeria in 1992 to that in 1993?
Provide a succinct answer. 0.46. What is the difference between the highest and the second highest ODA received (in %) in Bolivia?
Make the answer very short. 0.44. What is the difference between the highest and the second highest ODA received (in %) of El Salvador?
Make the answer very short. 0.62. What is the difference between the highest and the second highest ODA received (in %) in Malaysia?
Your answer should be very brief. 0.09. What is the difference between the highest and the second highest ODA received (in %) in Nigeria?
Give a very brief answer. 0.59. What is the difference between the highest and the lowest ODA received (in %) in Bolivia?
Provide a succinct answer. 4.69. What is the difference between the highest and the lowest ODA received (in %) of El Salvador?
Offer a terse response. 5.27. What is the difference between the highest and the lowest ODA received (in %) in Malaysia?
Your answer should be very brief. 1.05. What is the difference between the highest and the lowest ODA received (in %) in Nigeria?
Your response must be concise. 1.83. 